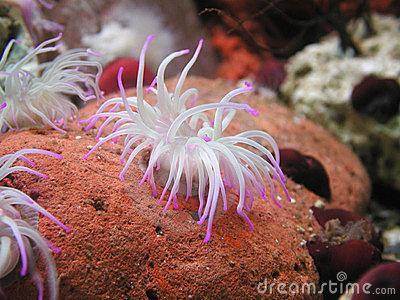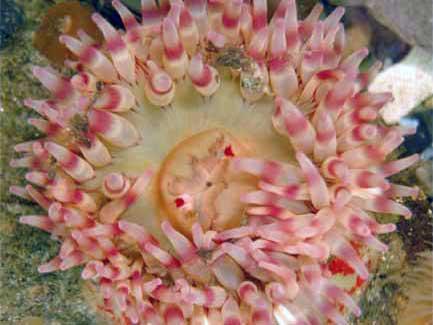The first image is the image on the left, the second image is the image on the right. Analyze the images presented: Is the assertion "Looking down from the top angle, into the colorful anemone pictured in the image on the right, reveals a central, mouth-like opening, surrounded by tentacles." valid? Answer yes or no. Yes. 